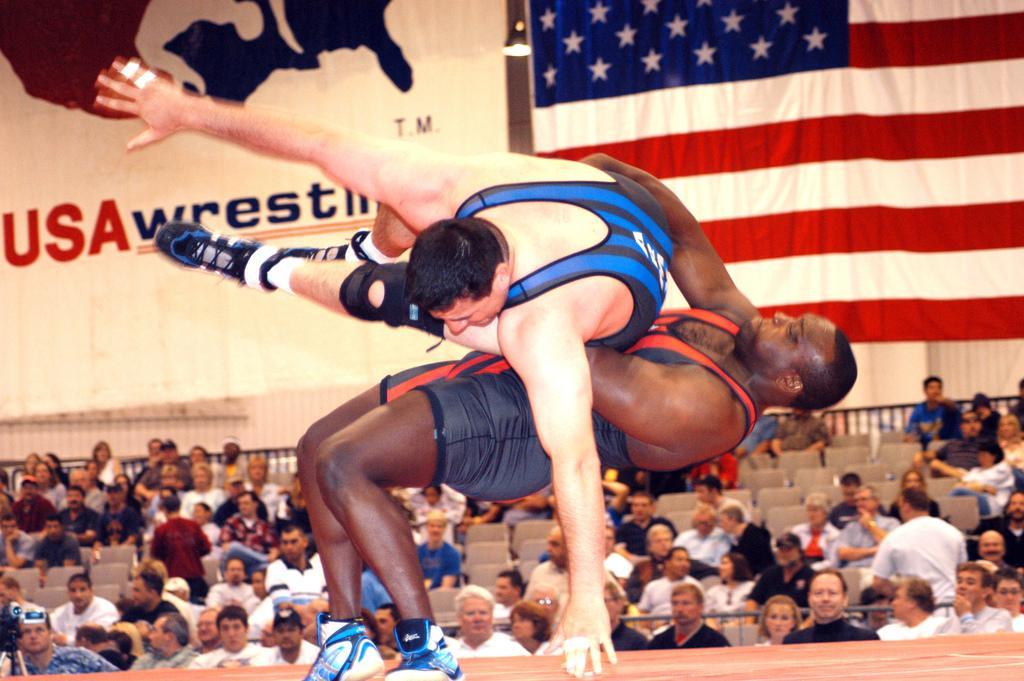Describe this image in one or two sentences. In this image I can see two persons playing wrestling. In the background I can see few persons sitting on the chairs. I can see a flag. I can see a banner with some text on it. 